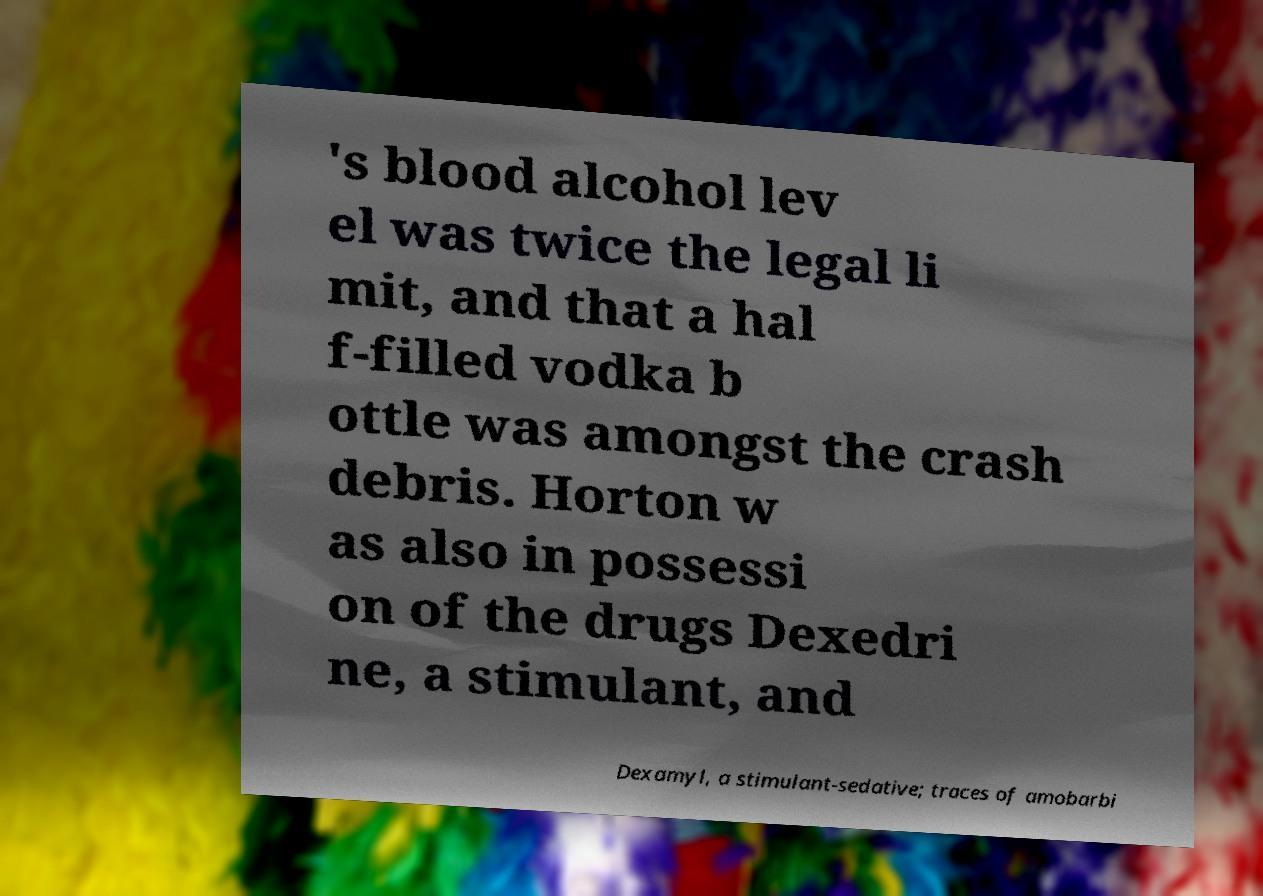Please read and relay the text visible in this image. What does it say? 's blood alcohol lev el was twice the legal li mit, and that a hal f-filled vodka b ottle was amongst the crash debris. Horton w as also in possessi on of the drugs Dexedri ne, a stimulant, and Dexamyl, a stimulant-sedative; traces of amobarbi 